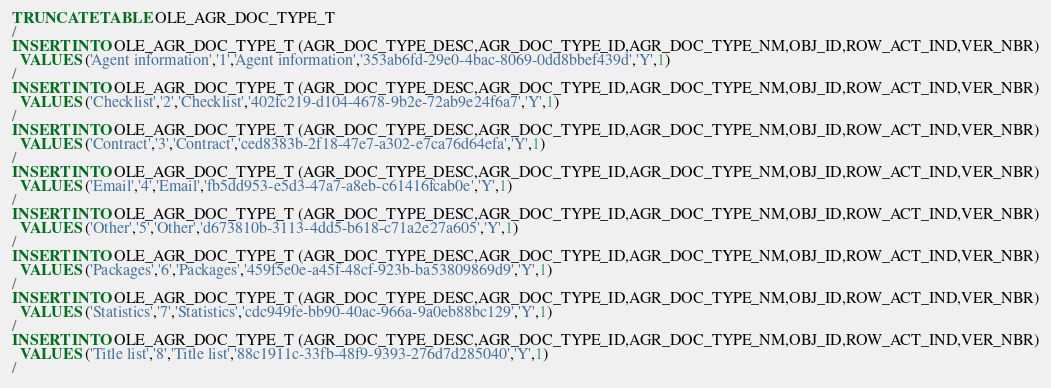<code> <loc_0><loc_0><loc_500><loc_500><_SQL_>TRUNCATE TABLE OLE_AGR_DOC_TYPE_T
/
INSERT INTO OLE_AGR_DOC_TYPE_T (AGR_DOC_TYPE_DESC,AGR_DOC_TYPE_ID,AGR_DOC_TYPE_NM,OBJ_ID,ROW_ACT_IND,VER_NBR)
  VALUES ('Agent information','1','Agent information','353ab6fd-29e0-4bac-8069-0dd8bbef439d','Y',1)
/
INSERT INTO OLE_AGR_DOC_TYPE_T (AGR_DOC_TYPE_DESC,AGR_DOC_TYPE_ID,AGR_DOC_TYPE_NM,OBJ_ID,ROW_ACT_IND,VER_NBR)
  VALUES ('Checklist','2','Checklist','402fc219-d104-4678-9b2e-72ab9e24f6a7','Y',1)
/
INSERT INTO OLE_AGR_DOC_TYPE_T (AGR_DOC_TYPE_DESC,AGR_DOC_TYPE_ID,AGR_DOC_TYPE_NM,OBJ_ID,ROW_ACT_IND,VER_NBR)
  VALUES ('Contract','3','Contract','ced8383b-2f18-47e7-a302-e7ca76d64efa','Y',1)
/
INSERT INTO OLE_AGR_DOC_TYPE_T (AGR_DOC_TYPE_DESC,AGR_DOC_TYPE_ID,AGR_DOC_TYPE_NM,OBJ_ID,ROW_ACT_IND,VER_NBR)
  VALUES ('Email','4','Email','fb5dd953-e5d3-47a7-a8eb-c61416fcab0e','Y',1)
/
INSERT INTO OLE_AGR_DOC_TYPE_T (AGR_DOC_TYPE_DESC,AGR_DOC_TYPE_ID,AGR_DOC_TYPE_NM,OBJ_ID,ROW_ACT_IND,VER_NBR)
  VALUES ('Other','5','Other','d673810b-3113-4dd5-b618-c71a2e27a605','Y',1)
/
INSERT INTO OLE_AGR_DOC_TYPE_T (AGR_DOC_TYPE_DESC,AGR_DOC_TYPE_ID,AGR_DOC_TYPE_NM,OBJ_ID,ROW_ACT_IND,VER_NBR)
  VALUES ('Packages','6','Packages','459f5e0e-a45f-48cf-923b-ba53809869d9','Y',1)
/
INSERT INTO OLE_AGR_DOC_TYPE_T (AGR_DOC_TYPE_DESC,AGR_DOC_TYPE_ID,AGR_DOC_TYPE_NM,OBJ_ID,ROW_ACT_IND,VER_NBR)
  VALUES ('Statistics','7','Statistics','cdc949fe-bb90-40ac-966a-9a0eb88bc129','Y',1)
/
INSERT INTO OLE_AGR_DOC_TYPE_T (AGR_DOC_TYPE_DESC,AGR_DOC_TYPE_ID,AGR_DOC_TYPE_NM,OBJ_ID,ROW_ACT_IND,VER_NBR)
  VALUES ('Title list','8','Title list','88c1911c-33fb-48f9-9393-276d7d285040','Y',1)
/
</code> 